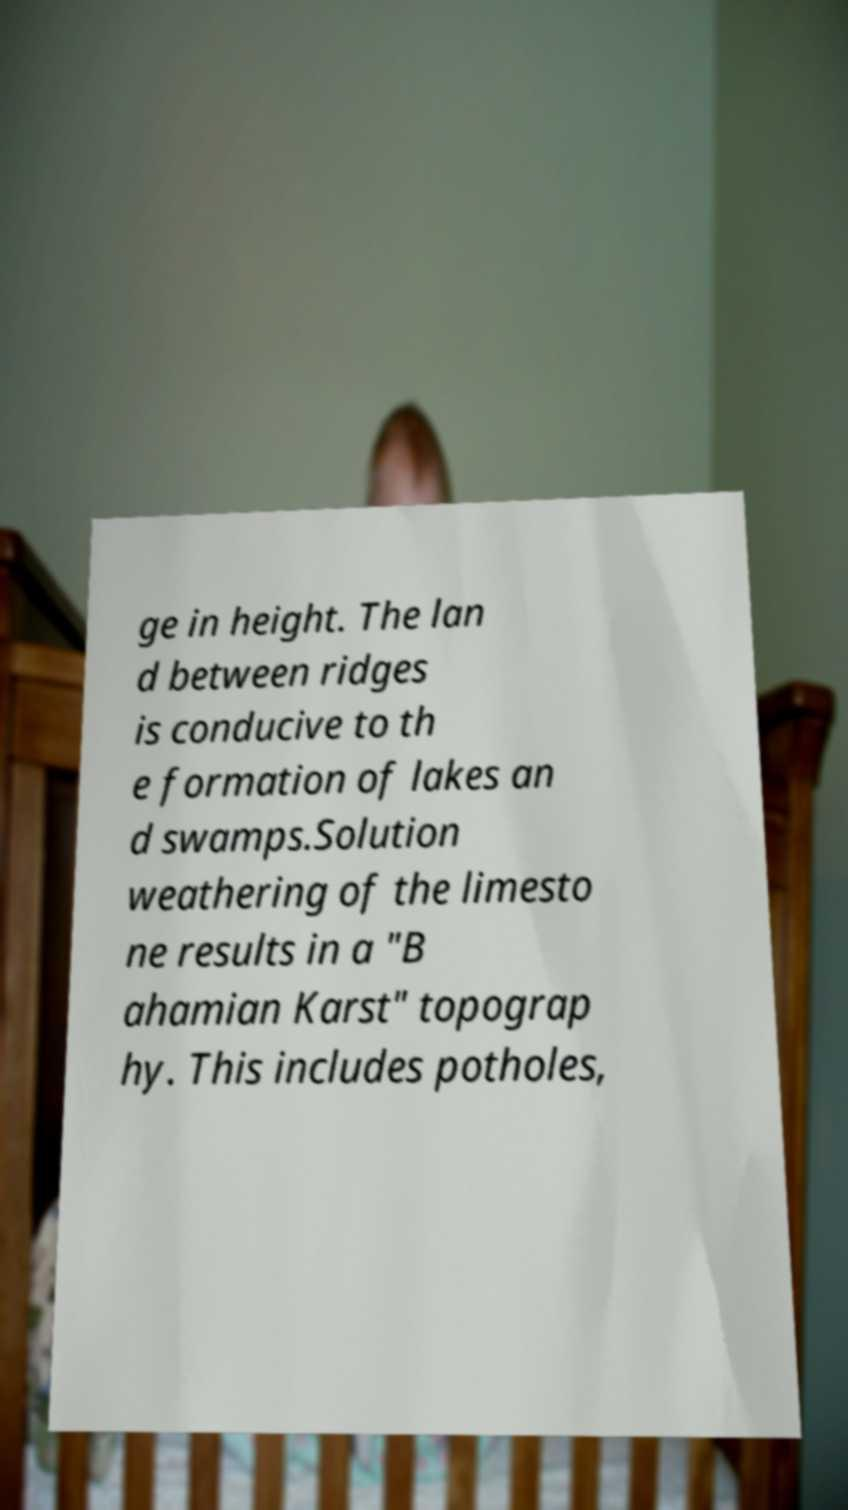For documentation purposes, I need the text within this image transcribed. Could you provide that? ge in height. The lan d between ridges is conducive to th e formation of lakes an d swamps.Solution weathering of the limesto ne results in a "B ahamian Karst" topograp hy. This includes potholes, 